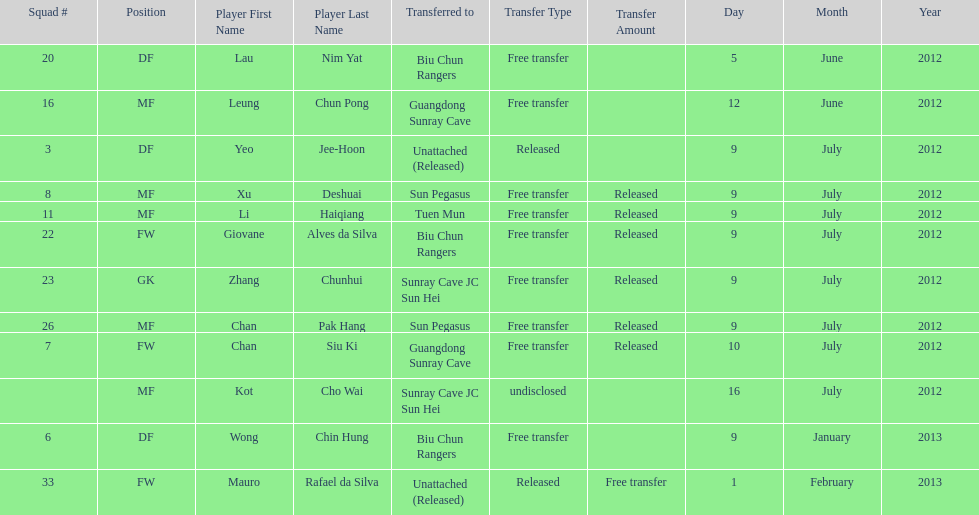Wong chin hung was transferred to his new team on what date? 9 January 2013. 